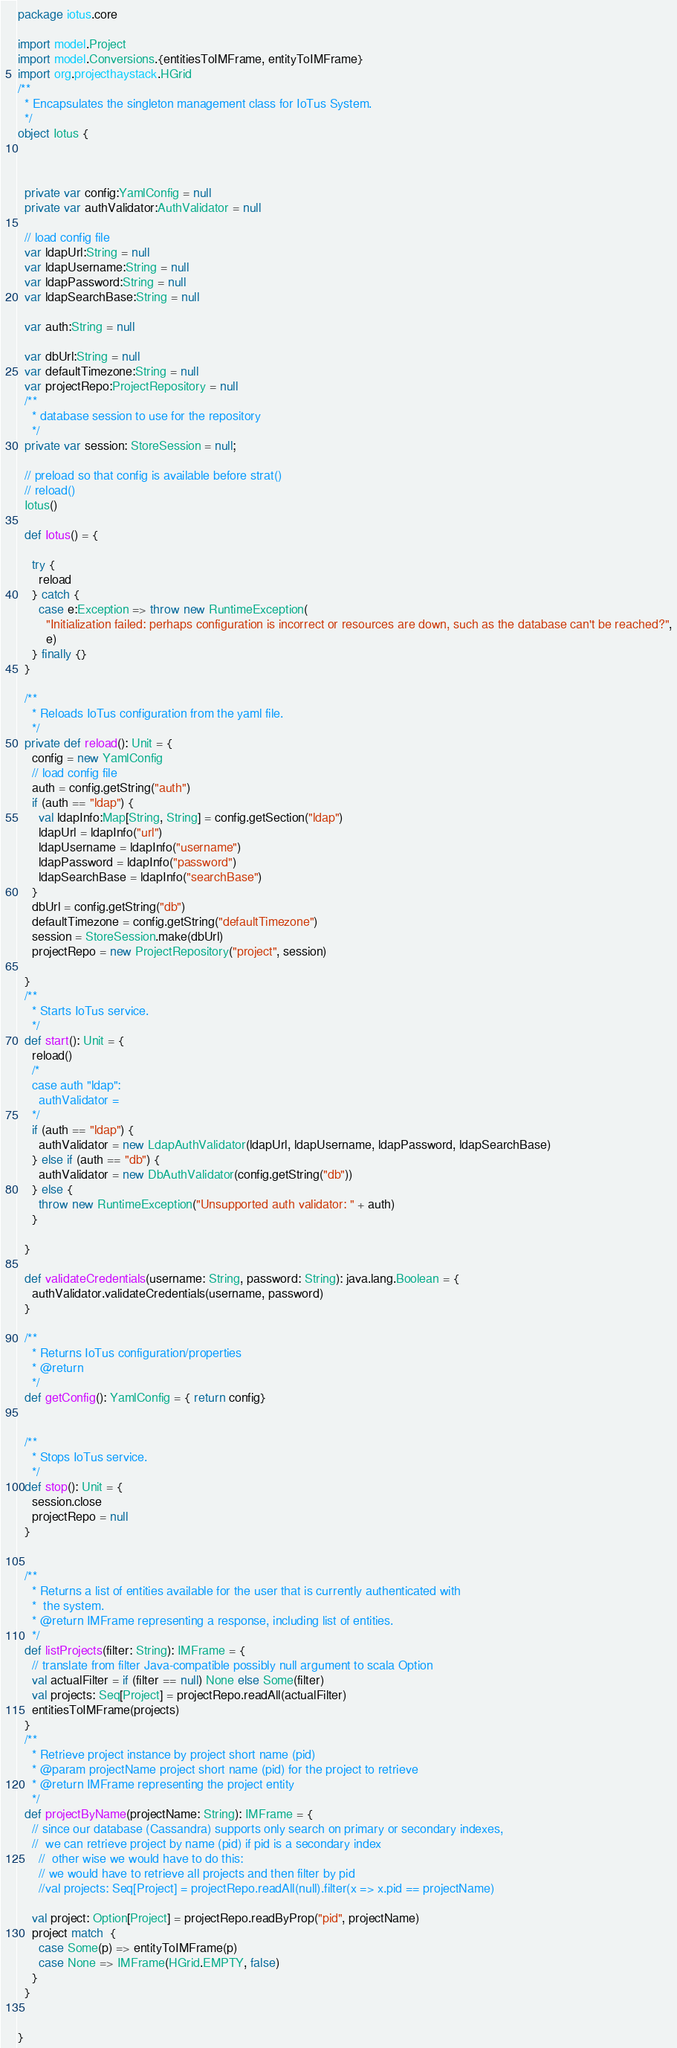Convert code to text. <code><loc_0><loc_0><loc_500><loc_500><_Scala_>package iotus.core

import model.Project
import model.Conversions.{entitiesToIMFrame, entityToIMFrame}
import org.projecthaystack.HGrid
/**
  * Encapsulates the singleton management class for IoTus System.
  */
object Iotus {



  private var config:YamlConfig = null
  private var authValidator:AuthValidator = null

  // load config file
  var ldapUrl:String = null
  var ldapUsername:String = null
  var ldapPassword:String = null
  var ldapSearchBase:String = null

  var auth:String = null

  var dbUrl:String = null
  var defaultTimezone:String = null
  var projectRepo:ProjectRepository = null
  /**
    * database session to use for the repository
    */
  private var session: StoreSession = null;

  // preload so that config is available before strat()
  // reload()
  Iotus()

  def Iotus() = {

    try {
      reload
    } catch {
      case e:Exception => throw new RuntimeException(
        "Initialization failed: perhaps configuration is incorrect or resources are down, such as the database can't be reached?",
        e)
    } finally {}
  }

  /**
    * Reloads IoTus configuration from the yaml file.
    */
  private def reload(): Unit = {
    config = new YamlConfig
    // load config file
    auth = config.getString("auth")
    if (auth == "ldap") {
      val ldapInfo:Map[String, String] = config.getSection("ldap")
      ldapUrl = ldapInfo("url")
      ldapUsername = ldapInfo("username")
      ldapPassword = ldapInfo("password")
      ldapSearchBase = ldapInfo("searchBase")
    }
    dbUrl = config.getString("db")
    defaultTimezone = config.getString("defaultTimezone")
    session = StoreSession.make(dbUrl)
    projectRepo = new ProjectRepository("project", session)

  }
  /**
    * Starts IoTus service.
    */
  def start(): Unit = {
    reload()
    /*
    case auth "ldap":
      authValidator =
    */
    if (auth == "ldap") {
      authValidator = new LdapAuthValidator(ldapUrl, ldapUsername, ldapPassword, ldapSearchBase)
    } else if (auth == "db") {
      authValidator = new DbAuthValidator(config.getString("db"))
    } else {
      throw new RuntimeException("Unsupported auth validator: " + auth)
    }

  }

  def validateCredentials(username: String, password: String): java.lang.Boolean = {
    authValidator.validateCredentials(username, password)
  }

  /**
    * Returns IoTus configuration/properties
    * @return
    */
  def getConfig(): YamlConfig = { return config}


  /**
    * Stops IoTus service.
    */
  def stop(): Unit = {
    session.close
    projectRepo = null
  }


  /**
    * Returns a list of entities available for the user that is currently authenticated with
    *  the system.
    * @return IMFrame representing a response, including list of entities.
    */
  def listProjects(filter: String): IMFrame = {
    // translate from filter Java-compatible possibly null argument to scala Option
    val actualFilter = if (filter == null) None else Some(filter)
    val projects: Seq[Project] = projectRepo.readAll(actualFilter)
    entitiesToIMFrame(projects)
  }
  /**
    * Retrieve project instance by project short name (pid)
    * @param projectName project short name (pid) for the project to retrieve
    * @return IMFrame representing the project entity
    */
  def projectByName(projectName: String): IMFrame = {
    // since our database (Cassandra) supports only search on primary or secondary indexes,
    //  we can retrieve project by name (pid) if pid is a secondary index
      //  other wise we would have to do this:
      // we would have to retrieve all projects and then filter by pid
      //val projects: Seq[Project] = projectRepo.readAll(null).filter(x => x.pid == projectName)

    val project: Option[Project] = projectRepo.readByProp("pid", projectName)
    project match  {
      case Some(p) => entityToIMFrame(p)
      case None => IMFrame(HGrid.EMPTY, false)
    }
  }


}</code> 